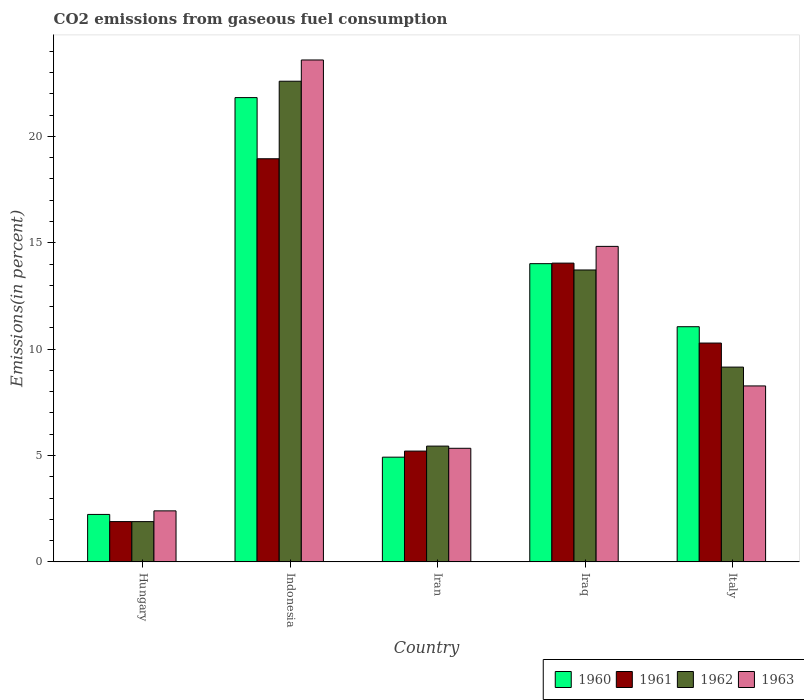How many groups of bars are there?
Your response must be concise. 5. Are the number of bars per tick equal to the number of legend labels?
Offer a very short reply. Yes. Are the number of bars on each tick of the X-axis equal?
Ensure brevity in your answer.  Yes. How many bars are there on the 3rd tick from the left?
Your answer should be compact. 4. How many bars are there on the 3rd tick from the right?
Offer a terse response. 4. What is the label of the 3rd group of bars from the left?
Ensure brevity in your answer.  Iran. What is the total CO2 emitted in 1961 in Indonesia?
Provide a succinct answer. 18.95. Across all countries, what is the maximum total CO2 emitted in 1962?
Your response must be concise. 22.6. Across all countries, what is the minimum total CO2 emitted in 1962?
Give a very brief answer. 1.89. In which country was the total CO2 emitted in 1963 maximum?
Keep it short and to the point. Indonesia. In which country was the total CO2 emitted in 1962 minimum?
Your answer should be compact. Hungary. What is the total total CO2 emitted in 1962 in the graph?
Offer a terse response. 52.81. What is the difference between the total CO2 emitted in 1963 in Indonesia and that in Italy?
Offer a very short reply. 15.32. What is the difference between the total CO2 emitted in 1963 in Iran and the total CO2 emitted in 1960 in Italy?
Offer a very short reply. -5.72. What is the average total CO2 emitted in 1962 per country?
Your response must be concise. 10.56. What is the difference between the total CO2 emitted of/in 1961 and total CO2 emitted of/in 1962 in Hungary?
Offer a very short reply. 0. What is the ratio of the total CO2 emitted in 1960 in Hungary to that in Indonesia?
Offer a terse response. 0.1. What is the difference between the highest and the second highest total CO2 emitted in 1963?
Your answer should be very brief. -6.56. What is the difference between the highest and the lowest total CO2 emitted in 1961?
Provide a succinct answer. 17.06. In how many countries, is the total CO2 emitted in 1963 greater than the average total CO2 emitted in 1963 taken over all countries?
Provide a short and direct response. 2. Is it the case that in every country, the sum of the total CO2 emitted in 1963 and total CO2 emitted in 1960 is greater than the sum of total CO2 emitted in 1962 and total CO2 emitted in 1961?
Your answer should be compact. No. What does the 4th bar from the left in Italy represents?
Offer a very short reply. 1963. What does the 2nd bar from the right in Iraq represents?
Make the answer very short. 1962. How many bars are there?
Ensure brevity in your answer.  20. Are all the bars in the graph horizontal?
Your answer should be very brief. No. Are the values on the major ticks of Y-axis written in scientific E-notation?
Offer a terse response. No. What is the title of the graph?
Your answer should be very brief. CO2 emissions from gaseous fuel consumption. What is the label or title of the Y-axis?
Offer a very short reply. Emissions(in percent). What is the Emissions(in percent) in 1960 in Hungary?
Make the answer very short. 2.23. What is the Emissions(in percent) in 1961 in Hungary?
Your answer should be very brief. 1.89. What is the Emissions(in percent) of 1962 in Hungary?
Keep it short and to the point. 1.89. What is the Emissions(in percent) of 1963 in Hungary?
Your response must be concise. 2.4. What is the Emissions(in percent) in 1960 in Indonesia?
Provide a short and direct response. 21.83. What is the Emissions(in percent) of 1961 in Indonesia?
Offer a very short reply. 18.95. What is the Emissions(in percent) of 1962 in Indonesia?
Your answer should be very brief. 22.6. What is the Emissions(in percent) of 1963 in Indonesia?
Your answer should be compact. 23.6. What is the Emissions(in percent) of 1960 in Iran?
Provide a short and direct response. 4.92. What is the Emissions(in percent) in 1961 in Iran?
Your answer should be compact. 5.21. What is the Emissions(in percent) in 1962 in Iran?
Your response must be concise. 5.44. What is the Emissions(in percent) of 1963 in Iran?
Your answer should be compact. 5.34. What is the Emissions(in percent) of 1960 in Iraq?
Make the answer very short. 14.02. What is the Emissions(in percent) of 1961 in Iraq?
Your answer should be very brief. 14.05. What is the Emissions(in percent) in 1962 in Iraq?
Your answer should be compact. 13.72. What is the Emissions(in percent) of 1963 in Iraq?
Offer a very short reply. 14.83. What is the Emissions(in percent) of 1960 in Italy?
Your answer should be compact. 11.06. What is the Emissions(in percent) in 1961 in Italy?
Your answer should be compact. 10.29. What is the Emissions(in percent) in 1962 in Italy?
Offer a terse response. 9.16. What is the Emissions(in percent) of 1963 in Italy?
Provide a short and direct response. 8.27. Across all countries, what is the maximum Emissions(in percent) in 1960?
Provide a succinct answer. 21.83. Across all countries, what is the maximum Emissions(in percent) of 1961?
Offer a very short reply. 18.95. Across all countries, what is the maximum Emissions(in percent) in 1962?
Offer a very short reply. 22.6. Across all countries, what is the maximum Emissions(in percent) in 1963?
Give a very brief answer. 23.6. Across all countries, what is the minimum Emissions(in percent) in 1960?
Make the answer very short. 2.23. Across all countries, what is the minimum Emissions(in percent) in 1961?
Provide a short and direct response. 1.89. Across all countries, what is the minimum Emissions(in percent) of 1962?
Keep it short and to the point. 1.89. Across all countries, what is the minimum Emissions(in percent) in 1963?
Your response must be concise. 2.4. What is the total Emissions(in percent) of 1960 in the graph?
Your answer should be very brief. 54.06. What is the total Emissions(in percent) in 1961 in the graph?
Give a very brief answer. 50.39. What is the total Emissions(in percent) in 1962 in the graph?
Offer a terse response. 52.81. What is the total Emissions(in percent) of 1963 in the graph?
Keep it short and to the point. 54.44. What is the difference between the Emissions(in percent) in 1960 in Hungary and that in Indonesia?
Ensure brevity in your answer.  -19.6. What is the difference between the Emissions(in percent) of 1961 in Hungary and that in Indonesia?
Offer a very short reply. -17.06. What is the difference between the Emissions(in percent) in 1962 in Hungary and that in Indonesia?
Your answer should be compact. -20.7. What is the difference between the Emissions(in percent) in 1963 in Hungary and that in Indonesia?
Offer a very short reply. -21.2. What is the difference between the Emissions(in percent) of 1960 in Hungary and that in Iran?
Offer a very short reply. -2.69. What is the difference between the Emissions(in percent) in 1961 in Hungary and that in Iran?
Offer a very short reply. -3.31. What is the difference between the Emissions(in percent) of 1962 in Hungary and that in Iran?
Make the answer very short. -3.55. What is the difference between the Emissions(in percent) in 1963 in Hungary and that in Iran?
Offer a very short reply. -2.94. What is the difference between the Emissions(in percent) in 1960 in Hungary and that in Iraq?
Ensure brevity in your answer.  -11.79. What is the difference between the Emissions(in percent) of 1961 in Hungary and that in Iraq?
Provide a short and direct response. -12.15. What is the difference between the Emissions(in percent) of 1962 in Hungary and that in Iraq?
Your answer should be compact. -11.83. What is the difference between the Emissions(in percent) in 1963 in Hungary and that in Iraq?
Your answer should be compact. -12.43. What is the difference between the Emissions(in percent) of 1960 in Hungary and that in Italy?
Give a very brief answer. -8.82. What is the difference between the Emissions(in percent) of 1961 in Hungary and that in Italy?
Ensure brevity in your answer.  -8.39. What is the difference between the Emissions(in percent) in 1962 in Hungary and that in Italy?
Keep it short and to the point. -7.26. What is the difference between the Emissions(in percent) of 1963 in Hungary and that in Italy?
Make the answer very short. -5.87. What is the difference between the Emissions(in percent) of 1960 in Indonesia and that in Iran?
Your response must be concise. 16.9. What is the difference between the Emissions(in percent) of 1961 in Indonesia and that in Iran?
Your answer should be very brief. 13.74. What is the difference between the Emissions(in percent) of 1962 in Indonesia and that in Iran?
Offer a very short reply. 17.15. What is the difference between the Emissions(in percent) in 1963 in Indonesia and that in Iran?
Provide a succinct answer. 18.26. What is the difference between the Emissions(in percent) of 1960 in Indonesia and that in Iraq?
Your response must be concise. 7.81. What is the difference between the Emissions(in percent) in 1961 in Indonesia and that in Iraq?
Ensure brevity in your answer.  4.91. What is the difference between the Emissions(in percent) of 1962 in Indonesia and that in Iraq?
Your answer should be compact. 8.87. What is the difference between the Emissions(in percent) in 1963 in Indonesia and that in Iraq?
Offer a terse response. 8.76. What is the difference between the Emissions(in percent) of 1960 in Indonesia and that in Italy?
Your response must be concise. 10.77. What is the difference between the Emissions(in percent) of 1961 in Indonesia and that in Italy?
Offer a very short reply. 8.66. What is the difference between the Emissions(in percent) of 1962 in Indonesia and that in Italy?
Provide a short and direct response. 13.44. What is the difference between the Emissions(in percent) of 1963 in Indonesia and that in Italy?
Your answer should be compact. 15.32. What is the difference between the Emissions(in percent) in 1960 in Iran and that in Iraq?
Offer a terse response. -9.1. What is the difference between the Emissions(in percent) of 1961 in Iran and that in Iraq?
Give a very brief answer. -8.84. What is the difference between the Emissions(in percent) in 1962 in Iran and that in Iraq?
Provide a succinct answer. -8.28. What is the difference between the Emissions(in percent) of 1963 in Iran and that in Iraq?
Offer a terse response. -9.49. What is the difference between the Emissions(in percent) of 1960 in Iran and that in Italy?
Give a very brief answer. -6.13. What is the difference between the Emissions(in percent) of 1961 in Iran and that in Italy?
Keep it short and to the point. -5.08. What is the difference between the Emissions(in percent) in 1962 in Iran and that in Italy?
Keep it short and to the point. -3.71. What is the difference between the Emissions(in percent) of 1963 in Iran and that in Italy?
Offer a terse response. -2.93. What is the difference between the Emissions(in percent) of 1960 in Iraq and that in Italy?
Offer a very short reply. 2.96. What is the difference between the Emissions(in percent) in 1961 in Iraq and that in Italy?
Make the answer very short. 3.76. What is the difference between the Emissions(in percent) of 1962 in Iraq and that in Italy?
Give a very brief answer. 4.57. What is the difference between the Emissions(in percent) in 1963 in Iraq and that in Italy?
Give a very brief answer. 6.56. What is the difference between the Emissions(in percent) in 1960 in Hungary and the Emissions(in percent) in 1961 in Indonesia?
Provide a short and direct response. -16.72. What is the difference between the Emissions(in percent) of 1960 in Hungary and the Emissions(in percent) of 1962 in Indonesia?
Give a very brief answer. -20.37. What is the difference between the Emissions(in percent) in 1960 in Hungary and the Emissions(in percent) in 1963 in Indonesia?
Make the answer very short. -21.36. What is the difference between the Emissions(in percent) in 1961 in Hungary and the Emissions(in percent) in 1962 in Indonesia?
Ensure brevity in your answer.  -20.7. What is the difference between the Emissions(in percent) of 1961 in Hungary and the Emissions(in percent) of 1963 in Indonesia?
Make the answer very short. -21.7. What is the difference between the Emissions(in percent) of 1962 in Hungary and the Emissions(in percent) of 1963 in Indonesia?
Offer a terse response. -21.7. What is the difference between the Emissions(in percent) in 1960 in Hungary and the Emissions(in percent) in 1961 in Iran?
Offer a terse response. -2.98. What is the difference between the Emissions(in percent) in 1960 in Hungary and the Emissions(in percent) in 1962 in Iran?
Your answer should be compact. -3.21. What is the difference between the Emissions(in percent) of 1960 in Hungary and the Emissions(in percent) of 1963 in Iran?
Your response must be concise. -3.11. What is the difference between the Emissions(in percent) of 1961 in Hungary and the Emissions(in percent) of 1962 in Iran?
Offer a terse response. -3.55. What is the difference between the Emissions(in percent) in 1961 in Hungary and the Emissions(in percent) in 1963 in Iran?
Keep it short and to the point. -3.45. What is the difference between the Emissions(in percent) in 1962 in Hungary and the Emissions(in percent) in 1963 in Iran?
Provide a succinct answer. -3.45. What is the difference between the Emissions(in percent) in 1960 in Hungary and the Emissions(in percent) in 1961 in Iraq?
Give a very brief answer. -11.81. What is the difference between the Emissions(in percent) of 1960 in Hungary and the Emissions(in percent) of 1962 in Iraq?
Offer a terse response. -11.49. What is the difference between the Emissions(in percent) of 1960 in Hungary and the Emissions(in percent) of 1963 in Iraq?
Your answer should be compact. -12.6. What is the difference between the Emissions(in percent) of 1961 in Hungary and the Emissions(in percent) of 1962 in Iraq?
Ensure brevity in your answer.  -11.83. What is the difference between the Emissions(in percent) in 1961 in Hungary and the Emissions(in percent) in 1963 in Iraq?
Provide a succinct answer. -12.94. What is the difference between the Emissions(in percent) in 1962 in Hungary and the Emissions(in percent) in 1963 in Iraq?
Offer a terse response. -12.94. What is the difference between the Emissions(in percent) of 1960 in Hungary and the Emissions(in percent) of 1961 in Italy?
Make the answer very short. -8.06. What is the difference between the Emissions(in percent) in 1960 in Hungary and the Emissions(in percent) in 1962 in Italy?
Give a very brief answer. -6.93. What is the difference between the Emissions(in percent) of 1960 in Hungary and the Emissions(in percent) of 1963 in Italy?
Your response must be concise. -6.04. What is the difference between the Emissions(in percent) in 1961 in Hungary and the Emissions(in percent) in 1962 in Italy?
Offer a very short reply. -7.26. What is the difference between the Emissions(in percent) in 1961 in Hungary and the Emissions(in percent) in 1963 in Italy?
Provide a succinct answer. -6.38. What is the difference between the Emissions(in percent) in 1962 in Hungary and the Emissions(in percent) in 1963 in Italy?
Provide a short and direct response. -6.38. What is the difference between the Emissions(in percent) of 1960 in Indonesia and the Emissions(in percent) of 1961 in Iran?
Give a very brief answer. 16.62. What is the difference between the Emissions(in percent) in 1960 in Indonesia and the Emissions(in percent) in 1962 in Iran?
Give a very brief answer. 16.38. What is the difference between the Emissions(in percent) of 1960 in Indonesia and the Emissions(in percent) of 1963 in Iran?
Provide a short and direct response. 16.49. What is the difference between the Emissions(in percent) of 1961 in Indonesia and the Emissions(in percent) of 1962 in Iran?
Your answer should be very brief. 13.51. What is the difference between the Emissions(in percent) in 1961 in Indonesia and the Emissions(in percent) in 1963 in Iran?
Offer a very short reply. 13.61. What is the difference between the Emissions(in percent) in 1962 in Indonesia and the Emissions(in percent) in 1963 in Iran?
Provide a succinct answer. 17.26. What is the difference between the Emissions(in percent) in 1960 in Indonesia and the Emissions(in percent) in 1961 in Iraq?
Provide a short and direct response. 7.78. What is the difference between the Emissions(in percent) in 1960 in Indonesia and the Emissions(in percent) in 1962 in Iraq?
Give a very brief answer. 8.1. What is the difference between the Emissions(in percent) in 1960 in Indonesia and the Emissions(in percent) in 1963 in Iraq?
Offer a terse response. 6.99. What is the difference between the Emissions(in percent) of 1961 in Indonesia and the Emissions(in percent) of 1962 in Iraq?
Your answer should be compact. 5.23. What is the difference between the Emissions(in percent) of 1961 in Indonesia and the Emissions(in percent) of 1963 in Iraq?
Make the answer very short. 4.12. What is the difference between the Emissions(in percent) of 1962 in Indonesia and the Emissions(in percent) of 1963 in Iraq?
Provide a short and direct response. 7.76. What is the difference between the Emissions(in percent) in 1960 in Indonesia and the Emissions(in percent) in 1961 in Italy?
Offer a terse response. 11.54. What is the difference between the Emissions(in percent) of 1960 in Indonesia and the Emissions(in percent) of 1962 in Italy?
Offer a terse response. 12.67. What is the difference between the Emissions(in percent) of 1960 in Indonesia and the Emissions(in percent) of 1963 in Italy?
Your response must be concise. 13.55. What is the difference between the Emissions(in percent) of 1961 in Indonesia and the Emissions(in percent) of 1962 in Italy?
Provide a succinct answer. 9.8. What is the difference between the Emissions(in percent) of 1961 in Indonesia and the Emissions(in percent) of 1963 in Italy?
Provide a succinct answer. 10.68. What is the difference between the Emissions(in percent) in 1962 in Indonesia and the Emissions(in percent) in 1963 in Italy?
Your response must be concise. 14.32. What is the difference between the Emissions(in percent) of 1960 in Iran and the Emissions(in percent) of 1961 in Iraq?
Your answer should be compact. -9.12. What is the difference between the Emissions(in percent) of 1960 in Iran and the Emissions(in percent) of 1962 in Iraq?
Offer a very short reply. -8.8. What is the difference between the Emissions(in percent) in 1960 in Iran and the Emissions(in percent) in 1963 in Iraq?
Provide a succinct answer. -9.91. What is the difference between the Emissions(in percent) in 1961 in Iran and the Emissions(in percent) in 1962 in Iraq?
Your response must be concise. -8.51. What is the difference between the Emissions(in percent) in 1961 in Iran and the Emissions(in percent) in 1963 in Iraq?
Offer a very short reply. -9.62. What is the difference between the Emissions(in percent) in 1962 in Iran and the Emissions(in percent) in 1963 in Iraq?
Offer a very short reply. -9.39. What is the difference between the Emissions(in percent) in 1960 in Iran and the Emissions(in percent) in 1961 in Italy?
Provide a short and direct response. -5.36. What is the difference between the Emissions(in percent) in 1960 in Iran and the Emissions(in percent) in 1962 in Italy?
Provide a short and direct response. -4.23. What is the difference between the Emissions(in percent) in 1960 in Iran and the Emissions(in percent) in 1963 in Italy?
Your answer should be very brief. -3.35. What is the difference between the Emissions(in percent) of 1961 in Iran and the Emissions(in percent) of 1962 in Italy?
Your response must be concise. -3.95. What is the difference between the Emissions(in percent) in 1961 in Iran and the Emissions(in percent) in 1963 in Italy?
Ensure brevity in your answer.  -3.06. What is the difference between the Emissions(in percent) of 1962 in Iran and the Emissions(in percent) of 1963 in Italy?
Give a very brief answer. -2.83. What is the difference between the Emissions(in percent) of 1960 in Iraq and the Emissions(in percent) of 1961 in Italy?
Keep it short and to the point. 3.73. What is the difference between the Emissions(in percent) in 1960 in Iraq and the Emissions(in percent) in 1962 in Italy?
Provide a short and direct response. 4.86. What is the difference between the Emissions(in percent) in 1960 in Iraq and the Emissions(in percent) in 1963 in Italy?
Provide a short and direct response. 5.75. What is the difference between the Emissions(in percent) in 1961 in Iraq and the Emissions(in percent) in 1962 in Italy?
Your answer should be very brief. 4.89. What is the difference between the Emissions(in percent) in 1961 in Iraq and the Emissions(in percent) in 1963 in Italy?
Your answer should be compact. 5.77. What is the difference between the Emissions(in percent) of 1962 in Iraq and the Emissions(in percent) of 1963 in Italy?
Ensure brevity in your answer.  5.45. What is the average Emissions(in percent) of 1960 per country?
Your response must be concise. 10.81. What is the average Emissions(in percent) of 1961 per country?
Your response must be concise. 10.08. What is the average Emissions(in percent) in 1962 per country?
Provide a succinct answer. 10.56. What is the average Emissions(in percent) in 1963 per country?
Your answer should be very brief. 10.89. What is the difference between the Emissions(in percent) of 1960 and Emissions(in percent) of 1961 in Hungary?
Your response must be concise. 0.34. What is the difference between the Emissions(in percent) of 1960 and Emissions(in percent) of 1962 in Hungary?
Provide a succinct answer. 0.34. What is the difference between the Emissions(in percent) in 1960 and Emissions(in percent) in 1963 in Hungary?
Your answer should be very brief. -0.17. What is the difference between the Emissions(in percent) in 1961 and Emissions(in percent) in 1962 in Hungary?
Make the answer very short. 0. What is the difference between the Emissions(in percent) of 1961 and Emissions(in percent) of 1963 in Hungary?
Give a very brief answer. -0.5. What is the difference between the Emissions(in percent) of 1962 and Emissions(in percent) of 1963 in Hungary?
Your answer should be very brief. -0.5. What is the difference between the Emissions(in percent) in 1960 and Emissions(in percent) in 1961 in Indonesia?
Ensure brevity in your answer.  2.87. What is the difference between the Emissions(in percent) in 1960 and Emissions(in percent) in 1962 in Indonesia?
Give a very brief answer. -0.77. What is the difference between the Emissions(in percent) of 1960 and Emissions(in percent) of 1963 in Indonesia?
Give a very brief answer. -1.77. What is the difference between the Emissions(in percent) in 1961 and Emissions(in percent) in 1962 in Indonesia?
Offer a very short reply. -3.64. What is the difference between the Emissions(in percent) in 1961 and Emissions(in percent) in 1963 in Indonesia?
Provide a succinct answer. -4.64. What is the difference between the Emissions(in percent) in 1962 and Emissions(in percent) in 1963 in Indonesia?
Offer a terse response. -1. What is the difference between the Emissions(in percent) in 1960 and Emissions(in percent) in 1961 in Iran?
Give a very brief answer. -0.29. What is the difference between the Emissions(in percent) of 1960 and Emissions(in percent) of 1962 in Iran?
Offer a terse response. -0.52. What is the difference between the Emissions(in percent) of 1960 and Emissions(in percent) of 1963 in Iran?
Give a very brief answer. -0.42. What is the difference between the Emissions(in percent) in 1961 and Emissions(in percent) in 1962 in Iran?
Your answer should be compact. -0.23. What is the difference between the Emissions(in percent) of 1961 and Emissions(in percent) of 1963 in Iran?
Your answer should be compact. -0.13. What is the difference between the Emissions(in percent) of 1962 and Emissions(in percent) of 1963 in Iran?
Offer a very short reply. 0.1. What is the difference between the Emissions(in percent) of 1960 and Emissions(in percent) of 1961 in Iraq?
Your response must be concise. -0.03. What is the difference between the Emissions(in percent) of 1960 and Emissions(in percent) of 1962 in Iraq?
Give a very brief answer. 0.3. What is the difference between the Emissions(in percent) of 1960 and Emissions(in percent) of 1963 in Iraq?
Your answer should be compact. -0.81. What is the difference between the Emissions(in percent) of 1961 and Emissions(in percent) of 1962 in Iraq?
Keep it short and to the point. 0.32. What is the difference between the Emissions(in percent) of 1961 and Emissions(in percent) of 1963 in Iraq?
Offer a terse response. -0.79. What is the difference between the Emissions(in percent) in 1962 and Emissions(in percent) in 1963 in Iraq?
Give a very brief answer. -1.11. What is the difference between the Emissions(in percent) of 1960 and Emissions(in percent) of 1961 in Italy?
Keep it short and to the point. 0.77. What is the difference between the Emissions(in percent) in 1960 and Emissions(in percent) in 1962 in Italy?
Offer a very short reply. 1.9. What is the difference between the Emissions(in percent) in 1960 and Emissions(in percent) in 1963 in Italy?
Provide a short and direct response. 2.78. What is the difference between the Emissions(in percent) of 1961 and Emissions(in percent) of 1962 in Italy?
Give a very brief answer. 1.13. What is the difference between the Emissions(in percent) of 1961 and Emissions(in percent) of 1963 in Italy?
Provide a succinct answer. 2.02. What is the difference between the Emissions(in percent) in 1962 and Emissions(in percent) in 1963 in Italy?
Make the answer very short. 0.88. What is the ratio of the Emissions(in percent) of 1960 in Hungary to that in Indonesia?
Keep it short and to the point. 0.1. What is the ratio of the Emissions(in percent) in 1961 in Hungary to that in Indonesia?
Offer a terse response. 0.1. What is the ratio of the Emissions(in percent) in 1962 in Hungary to that in Indonesia?
Your answer should be very brief. 0.08. What is the ratio of the Emissions(in percent) in 1963 in Hungary to that in Indonesia?
Offer a terse response. 0.1. What is the ratio of the Emissions(in percent) of 1960 in Hungary to that in Iran?
Your answer should be very brief. 0.45. What is the ratio of the Emissions(in percent) of 1961 in Hungary to that in Iran?
Keep it short and to the point. 0.36. What is the ratio of the Emissions(in percent) in 1962 in Hungary to that in Iran?
Your response must be concise. 0.35. What is the ratio of the Emissions(in percent) of 1963 in Hungary to that in Iran?
Give a very brief answer. 0.45. What is the ratio of the Emissions(in percent) of 1960 in Hungary to that in Iraq?
Ensure brevity in your answer.  0.16. What is the ratio of the Emissions(in percent) of 1961 in Hungary to that in Iraq?
Your answer should be very brief. 0.13. What is the ratio of the Emissions(in percent) in 1962 in Hungary to that in Iraq?
Make the answer very short. 0.14. What is the ratio of the Emissions(in percent) in 1963 in Hungary to that in Iraq?
Provide a short and direct response. 0.16. What is the ratio of the Emissions(in percent) in 1960 in Hungary to that in Italy?
Your answer should be very brief. 0.2. What is the ratio of the Emissions(in percent) of 1961 in Hungary to that in Italy?
Your response must be concise. 0.18. What is the ratio of the Emissions(in percent) of 1962 in Hungary to that in Italy?
Offer a terse response. 0.21. What is the ratio of the Emissions(in percent) of 1963 in Hungary to that in Italy?
Provide a succinct answer. 0.29. What is the ratio of the Emissions(in percent) in 1960 in Indonesia to that in Iran?
Make the answer very short. 4.43. What is the ratio of the Emissions(in percent) in 1961 in Indonesia to that in Iran?
Provide a succinct answer. 3.64. What is the ratio of the Emissions(in percent) in 1962 in Indonesia to that in Iran?
Your answer should be very brief. 4.15. What is the ratio of the Emissions(in percent) of 1963 in Indonesia to that in Iran?
Provide a succinct answer. 4.42. What is the ratio of the Emissions(in percent) in 1960 in Indonesia to that in Iraq?
Provide a succinct answer. 1.56. What is the ratio of the Emissions(in percent) in 1961 in Indonesia to that in Iraq?
Offer a very short reply. 1.35. What is the ratio of the Emissions(in percent) in 1962 in Indonesia to that in Iraq?
Your response must be concise. 1.65. What is the ratio of the Emissions(in percent) in 1963 in Indonesia to that in Iraq?
Give a very brief answer. 1.59. What is the ratio of the Emissions(in percent) in 1960 in Indonesia to that in Italy?
Make the answer very short. 1.97. What is the ratio of the Emissions(in percent) in 1961 in Indonesia to that in Italy?
Offer a terse response. 1.84. What is the ratio of the Emissions(in percent) of 1962 in Indonesia to that in Italy?
Offer a very short reply. 2.47. What is the ratio of the Emissions(in percent) of 1963 in Indonesia to that in Italy?
Your answer should be compact. 2.85. What is the ratio of the Emissions(in percent) of 1960 in Iran to that in Iraq?
Your answer should be compact. 0.35. What is the ratio of the Emissions(in percent) of 1961 in Iran to that in Iraq?
Provide a succinct answer. 0.37. What is the ratio of the Emissions(in percent) of 1962 in Iran to that in Iraq?
Offer a very short reply. 0.4. What is the ratio of the Emissions(in percent) of 1963 in Iran to that in Iraq?
Your answer should be very brief. 0.36. What is the ratio of the Emissions(in percent) in 1960 in Iran to that in Italy?
Offer a terse response. 0.45. What is the ratio of the Emissions(in percent) in 1961 in Iran to that in Italy?
Offer a very short reply. 0.51. What is the ratio of the Emissions(in percent) of 1962 in Iran to that in Italy?
Keep it short and to the point. 0.59. What is the ratio of the Emissions(in percent) in 1963 in Iran to that in Italy?
Ensure brevity in your answer.  0.65. What is the ratio of the Emissions(in percent) of 1960 in Iraq to that in Italy?
Your answer should be compact. 1.27. What is the ratio of the Emissions(in percent) of 1961 in Iraq to that in Italy?
Your answer should be compact. 1.37. What is the ratio of the Emissions(in percent) in 1962 in Iraq to that in Italy?
Provide a short and direct response. 1.5. What is the ratio of the Emissions(in percent) of 1963 in Iraq to that in Italy?
Your response must be concise. 1.79. What is the difference between the highest and the second highest Emissions(in percent) in 1960?
Provide a short and direct response. 7.81. What is the difference between the highest and the second highest Emissions(in percent) of 1961?
Your answer should be compact. 4.91. What is the difference between the highest and the second highest Emissions(in percent) in 1962?
Your answer should be very brief. 8.87. What is the difference between the highest and the second highest Emissions(in percent) of 1963?
Your response must be concise. 8.76. What is the difference between the highest and the lowest Emissions(in percent) of 1960?
Give a very brief answer. 19.6. What is the difference between the highest and the lowest Emissions(in percent) in 1961?
Offer a terse response. 17.06. What is the difference between the highest and the lowest Emissions(in percent) of 1962?
Ensure brevity in your answer.  20.7. What is the difference between the highest and the lowest Emissions(in percent) in 1963?
Offer a terse response. 21.2. 